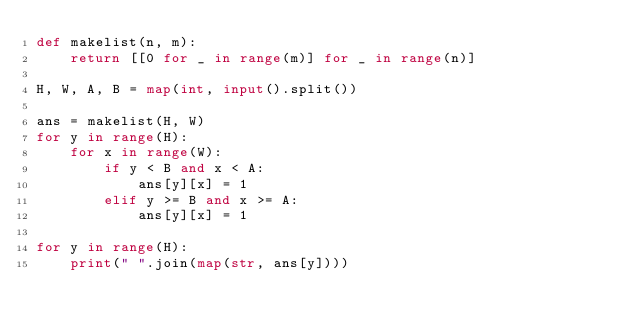<code> <loc_0><loc_0><loc_500><loc_500><_Python_>def makelist(n, m):
    return [[0 for _ in range(m)] for _ in range(n)]

H, W, A, B = map(int, input().split())

ans = makelist(H, W)
for y in range(H):
    for x in range(W):
        if y < B and x < A:
            ans[y][x] = 1
        elif y >= B and x >= A:
            ans[y][x] = 1

for y in range(H):
    print(" ".join(map(str, ans[y])))
</code> 